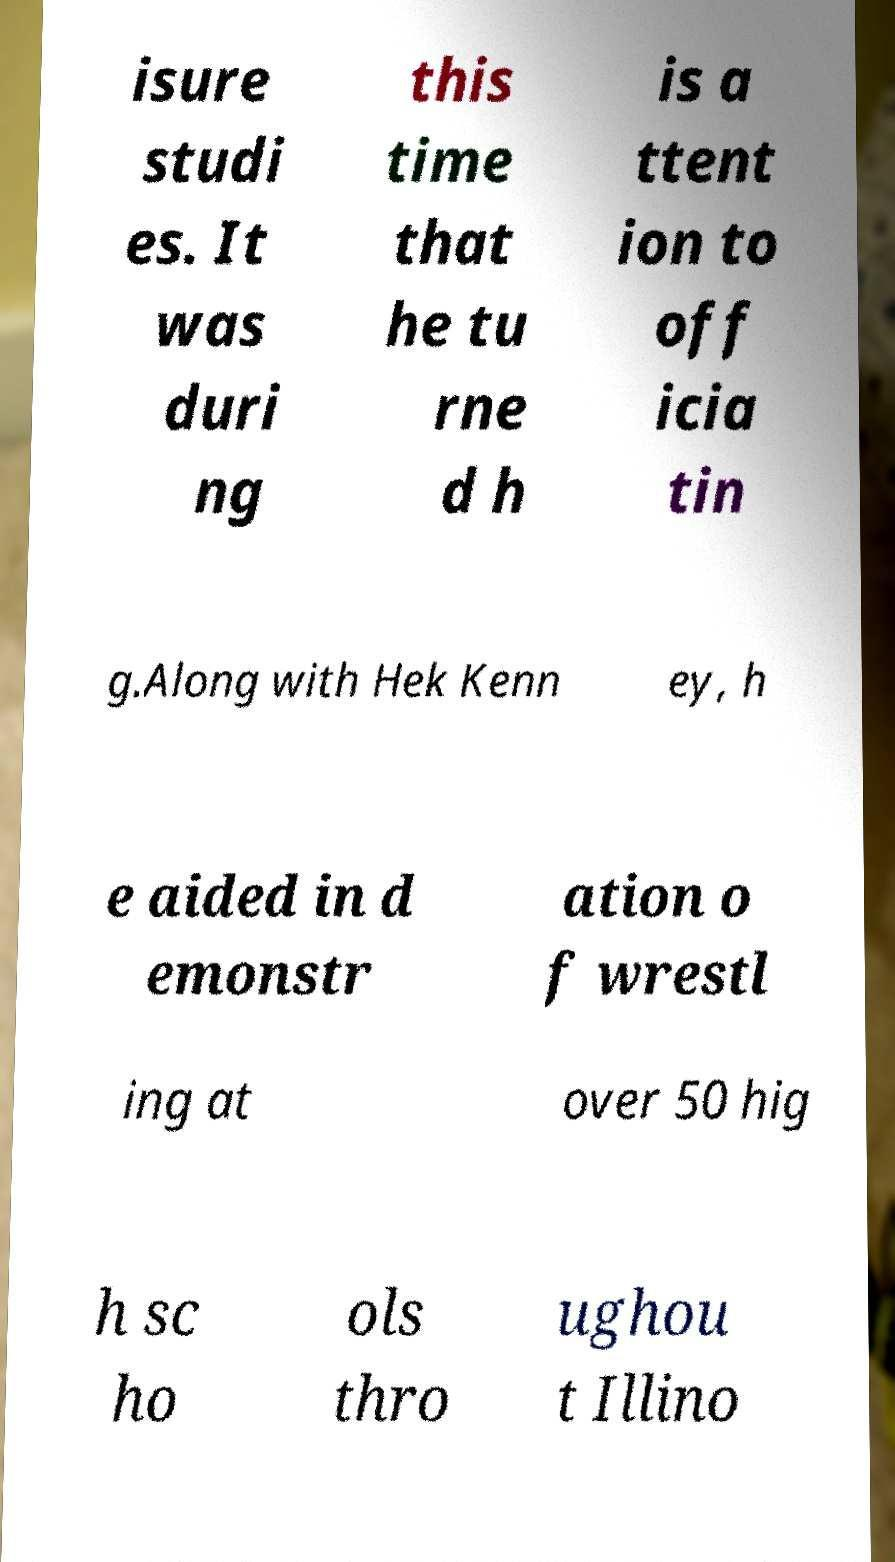There's text embedded in this image that I need extracted. Can you transcribe it verbatim? isure studi es. It was duri ng this time that he tu rne d h is a ttent ion to off icia tin g.Along with Hek Kenn ey, h e aided in d emonstr ation o f wrestl ing at over 50 hig h sc ho ols thro ughou t Illino 